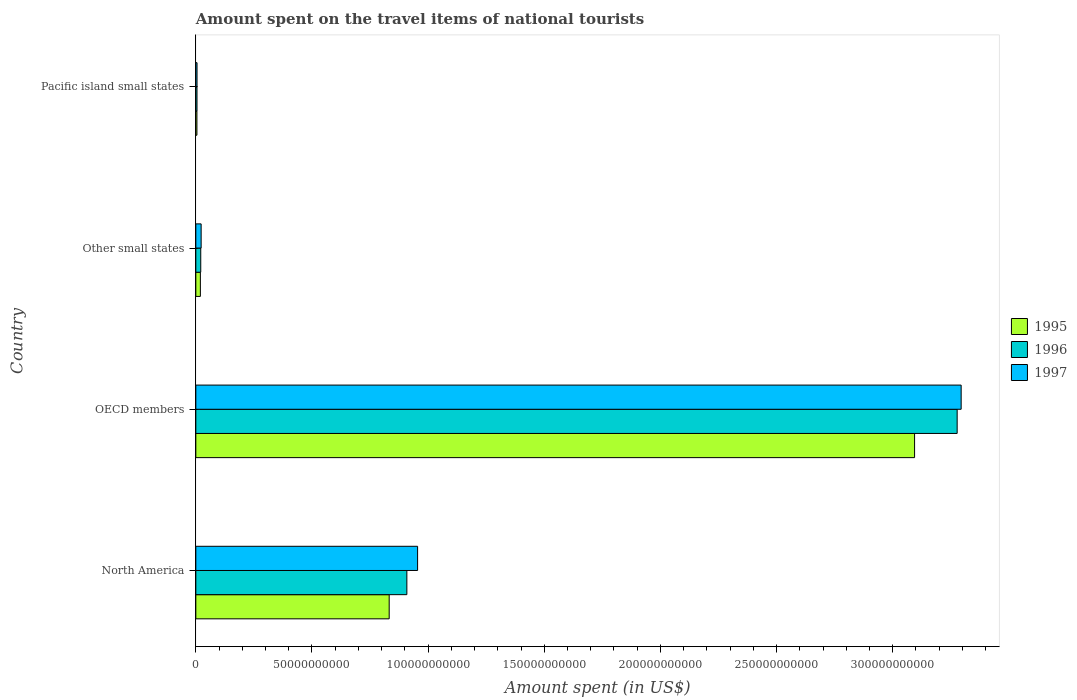How many different coloured bars are there?
Make the answer very short. 3. Are the number of bars on each tick of the Y-axis equal?
Keep it short and to the point. Yes. How many bars are there on the 1st tick from the top?
Provide a succinct answer. 3. How many bars are there on the 2nd tick from the bottom?
Provide a succinct answer. 3. What is the label of the 3rd group of bars from the top?
Ensure brevity in your answer.  OECD members. What is the amount spent on the travel items of national tourists in 1995 in Other small states?
Provide a succinct answer. 1.95e+09. Across all countries, what is the maximum amount spent on the travel items of national tourists in 1995?
Your answer should be very brief. 3.09e+11. Across all countries, what is the minimum amount spent on the travel items of national tourists in 1997?
Offer a very short reply. 5.15e+08. In which country was the amount spent on the travel items of national tourists in 1997 minimum?
Your answer should be compact. Pacific island small states. What is the total amount spent on the travel items of national tourists in 1997 in the graph?
Offer a very short reply. 4.28e+11. What is the difference between the amount spent on the travel items of national tourists in 1996 in OECD members and that in Other small states?
Ensure brevity in your answer.  3.26e+11. What is the difference between the amount spent on the travel items of national tourists in 1995 in North America and the amount spent on the travel items of national tourists in 1997 in Pacific island small states?
Provide a short and direct response. 8.27e+1. What is the average amount spent on the travel items of national tourists in 1996 per country?
Keep it short and to the point. 1.05e+11. What is the difference between the amount spent on the travel items of national tourists in 1995 and amount spent on the travel items of national tourists in 1996 in Pacific island small states?
Your answer should be very brief. -2.89e+07. What is the ratio of the amount spent on the travel items of national tourists in 1995 in OECD members to that in Other small states?
Keep it short and to the point. 158.36. What is the difference between the highest and the second highest amount spent on the travel items of national tourists in 1997?
Your response must be concise. 2.34e+11. What is the difference between the highest and the lowest amount spent on the travel items of national tourists in 1997?
Make the answer very short. 3.29e+11. In how many countries, is the amount spent on the travel items of national tourists in 1996 greater than the average amount spent on the travel items of national tourists in 1996 taken over all countries?
Give a very brief answer. 1. Is the sum of the amount spent on the travel items of national tourists in 1997 in North America and Other small states greater than the maximum amount spent on the travel items of national tourists in 1996 across all countries?
Keep it short and to the point. No. How many bars are there?
Provide a short and direct response. 12. What is the difference between two consecutive major ticks on the X-axis?
Your response must be concise. 5.00e+1. Are the values on the major ticks of X-axis written in scientific E-notation?
Make the answer very short. No. Does the graph contain any zero values?
Offer a very short reply. No. How are the legend labels stacked?
Your answer should be very brief. Vertical. What is the title of the graph?
Provide a short and direct response. Amount spent on the travel items of national tourists. Does "1989" appear as one of the legend labels in the graph?
Your answer should be compact. No. What is the label or title of the X-axis?
Provide a succinct answer. Amount spent (in US$). What is the label or title of the Y-axis?
Make the answer very short. Country. What is the Amount spent (in US$) in 1995 in North America?
Provide a short and direct response. 8.32e+1. What is the Amount spent (in US$) in 1996 in North America?
Give a very brief answer. 9.09e+1. What is the Amount spent (in US$) in 1997 in North America?
Your answer should be compact. 9.55e+1. What is the Amount spent (in US$) of 1995 in OECD members?
Make the answer very short. 3.09e+11. What is the Amount spent (in US$) of 1996 in OECD members?
Make the answer very short. 3.28e+11. What is the Amount spent (in US$) in 1997 in OECD members?
Provide a short and direct response. 3.29e+11. What is the Amount spent (in US$) of 1995 in Other small states?
Provide a succinct answer. 1.95e+09. What is the Amount spent (in US$) of 1996 in Other small states?
Ensure brevity in your answer.  2.12e+09. What is the Amount spent (in US$) in 1997 in Other small states?
Give a very brief answer. 2.29e+09. What is the Amount spent (in US$) of 1995 in Pacific island small states?
Give a very brief answer. 4.74e+08. What is the Amount spent (in US$) of 1996 in Pacific island small states?
Your response must be concise. 5.03e+08. What is the Amount spent (in US$) of 1997 in Pacific island small states?
Your answer should be compact. 5.15e+08. Across all countries, what is the maximum Amount spent (in US$) in 1995?
Keep it short and to the point. 3.09e+11. Across all countries, what is the maximum Amount spent (in US$) in 1996?
Your answer should be very brief. 3.28e+11. Across all countries, what is the maximum Amount spent (in US$) in 1997?
Make the answer very short. 3.29e+11. Across all countries, what is the minimum Amount spent (in US$) of 1995?
Your answer should be very brief. 4.74e+08. Across all countries, what is the minimum Amount spent (in US$) in 1996?
Your answer should be very brief. 5.03e+08. Across all countries, what is the minimum Amount spent (in US$) in 1997?
Offer a very short reply. 5.15e+08. What is the total Amount spent (in US$) in 1995 in the graph?
Your answer should be compact. 3.95e+11. What is the total Amount spent (in US$) of 1996 in the graph?
Give a very brief answer. 4.21e+11. What is the total Amount spent (in US$) in 1997 in the graph?
Make the answer very short. 4.28e+11. What is the difference between the Amount spent (in US$) of 1995 in North America and that in OECD members?
Your answer should be very brief. -2.26e+11. What is the difference between the Amount spent (in US$) of 1996 in North America and that in OECD members?
Offer a terse response. -2.37e+11. What is the difference between the Amount spent (in US$) of 1997 in North America and that in OECD members?
Make the answer very short. -2.34e+11. What is the difference between the Amount spent (in US$) of 1995 in North America and that in Other small states?
Provide a succinct answer. 8.13e+1. What is the difference between the Amount spent (in US$) of 1996 in North America and that in Other small states?
Provide a short and direct response. 8.87e+1. What is the difference between the Amount spent (in US$) in 1997 in North America and that in Other small states?
Offer a very short reply. 9.32e+1. What is the difference between the Amount spent (in US$) of 1995 in North America and that in Pacific island small states?
Your response must be concise. 8.28e+1. What is the difference between the Amount spent (in US$) of 1996 in North America and that in Pacific island small states?
Ensure brevity in your answer.  9.03e+1. What is the difference between the Amount spent (in US$) in 1997 in North America and that in Pacific island small states?
Provide a succinct answer. 9.50e+1. What is the difference between the Amount spent (in US$) of 1995 in OECD members and that in Other small states?
Ensure brevity in your answer.  3.07e+11. What is the difference between the Amount spent (in US$) in 1996 in OECD members and that in Other small states?
Your answer should be compact. 3.26e+11. What is the difference between the Amount spent (in US$) in 1997 in OECD members and that in Other small states?
Your response must be concise. 3.27e+11. What is the difference between the Amount spent (in US$) of 1995 in OECD members and that in Pacific island small states?
Keep it short and to the point. 3.09e+11. What is the difference between the Amount spent (in US$) in 1996 in OECD members and that in Pacific island small states?
Keep it short and to the point. 3.27e+11. What is the difference between the Amount spent (in US$) in 1997 in OECD members and that in Pacific island small states?
Provide a short and direct response. 3.29e+11. What is the difference between the Amount spent (in US$) in 1995 in Other small states and that in Pacific island small states?
Keep it short and to the point. 1.48e+09. What is the difference between the Amount spent (in US$) in 1996 in Other small states and that in Pacific island small states?
Provide a succinct answer. 1.62e+09. What is the difference between the Amount spent (in US$) of 1997 in Other small states and that in Pacific island small states?
Your answer should be very brief. 1.77e+09. What is the difference between the Amount spent (in US$) of 1995 in North America and the Amount spent (in US$) of 1996 in OECD members?
Make the answer very short. -2.45e+11. What is the difference between the Amount spent (in US$) of 1995 in North America and the Amount spent (in US$) of 1997 in OECD members?
Provide a succinct answer. -2.46e+11. What is the difference between the Amount spent (in US$) in 1996 in North America and the Amount spent (in US$) in 1997 in OECD members?
Your answer should be very brief. -2.39e+11. What is the difference between the Amount spent (in US$) of 1995 in North America and the Amount spent (in US$) of 1996 in Other small states?
Make the answer very short. 8.11e+1. What is the difference between the Amount spent (in US$) in 1995 in North America and the Amount spent (in US$) in 1997 in Other small states?
Offer a very short reply. 8.10e+1. What is the difference between the Amount spent (in US$) of 1996 in North America and the Amount spent (in US$) of 1997 in Other small states?
Your response must be concise. 8.86e+1. What is the difference between the Amount spent (in US$) of 1995 in North America and the Amount spent (in US$) of 1996 in Pacific island small states?
Provide a succinct answer. 8.27e+1. What is the difference between the Amount spent (in US$) of 1995 in North America and the Amount spent (in US$) of 1997 in Pacific island small states?
Offer a terse response. 8.27e+1. What is the difference between the Amount spent (in US$) of 1996 in North America and the Amount spent (in US$) of 1997 in Pacific island small states?
Your response must be concise. 9.03e+1. What is the difference between the Amount spent (in US$) of 1995 in OECD members and the Amount spent (in US$) of 1996 in Other small states?
Give a very brief answer. 3.07e+11. What is the difference between the Amount spent (in US$) of 1995 in OECD members and the Amount spent (in US$) of 1997 in Other small states?
Offer a terse response. 3.07e+11. What is the difference between the Amount spent (in US$) of 1996 in OECD members and the Amount spent (in US$) of 1997 in Other small states?
Provide a short and direct response. 3.25e+11. What is the difference between the Amount spent (in US$) in 1995 in OECD members and the Amount spent (in US$) in 1996 in Pacific island small states?
Your answer should be compact. 3.09e+11. What is the difference between the Amount spent (in US$) of 1995 in OECD members and the Amount spent (in US$) of 1997 in Pacific island small states?
Ensure brevity in your answer.  3.09e+11. What is the difference between the Amount spent (in US$) of 1996 in OECD members and the Amount spent (in US$) of 1997 in Pacific island small states?
Provide a succinct answer. 3.27e+11. What is the difference between the Amount spent (in US$) in 1995 in Other small states and the Amount spent (in US$) in 1996 in Pacific island small states?
Your response must be concise. 1.45e+09. What is the difference between the Amount spent (in US$) of 1995 in Other small states and the Amount spent (in US$) of 1997 in Pacific island small states?
Your answer should be compact. 1.44e+09. What is the difference between the Amount spent (in US$) in 1996 in Other small states and the Amount spent (in US$) in 1997 in Pacific island small states?
Your answer should be compact. 1.60e+09. What is the average Amount spent (in US$) of 1995 per country?
Offer a terse response. 9.88e+1. What is the average Amount spent (in US$) of 1996 per country?
Provide a succinct answer. 1.05e+11. What is the average Amount spent (in US$) of 1997 per country?
Provide a succinct answer. 1.07e+11. What is the difference between the Amount spent (in US$) of 1995 and Amount spent (in US$) of 1996 in North America?
Give a very brief answer. -7.61e+09. What is the difference between the Amount spent (in US$) of 1995 and Amount spent (in US$) of 1997 in North America?
Your response must be concise. -1.22e+1. What is the difference between the Amount spent (in US$) in 1996 and Amount spent (in US$) in 1997 in North America?
Your answer should be very brief. -4.62e+09. What is the difference between the Amount spent (in US$) of 1995 and Amount spent (in US$) of 1996 in OECD members?
Ensure brevity in your answer.  -1.83e+1. What is the difference between the Amount spent (in US$) of 1995 and Amount spent (in US$) of 1997 in OECD members?
Provide a short and direct response. -2.01e+1. What is the difference between the Amount spent (in US$) of 1996 and Amount spent (in US$) of 1997 in OECD members?
Ensure brevity in your answer.  -1.72e+09. What is the difference between the Amount spent (in US$) in 1995 and Amount spent (in US$) in 1996 in Other small states?
Your response must be concise. -1.64e+08. What is the difference between the Amount spent (in US$) of 1995 and Amount spent (in US$) of 1997 in Other small states?
Provide a short and direct response. -3.34e+08. What is the difference between the Amount spent (in US$) in 1996 and Amount spent (in US$) in 1997 in Other small states?
Provide a short and direct response. -1.69e+08. What is the difference between the Amount spent (in US$) in 1995 and Amount spent (in US$) in 1996 in Pacific island small states?
Your answer should be very brief. -2.89e+07. What is the difference between the Amount spent (in US$) of 1995 and Amount spent (in US$) of 1997 in Pacific island small states?
Provide a succinct answer. -4.11e+07. What is the difference between the Amount spent (in US$) of 1996 and Amount spent (in US$) of 1997 in Pacific island small states?
Keep it short and to the point. -1.22e+07. What is the ratio of the Amount spent (in US$) of 1995 in North America to that in OECD members?
Give a very brief answer. 0.27. What is the ratio of the Amount spent (in US$) in 1996 in North America to that in OECD members?
Provide a succinct answer. 0.28. What is the ratio of the Amount spent (in US$) of 1997 in North America to that in OECD members?
Give a very brief answer. 0.29. What is the ratio of the Amount spent (in US$) in 1995 in North America to that in Other small states?
Make the answer very short. 42.6. What is the ratio of the Amount spent (in US$) in 1996 in North America to that in Other small states?
Ensure brevity in your answer.  42.89. What is the ratio of the Amount spent (in US$) of 1997 in North America to that in Other small states?
Provide a succinct answer. 41.73. What is the ratio of the Amount spent (in US$) of 1995 in North America to that in Pacific island small states?
Your answer should be very brief. 175.63. What is the ratio of the Amount spent (in US$) of 1996 in North America to that in Pacific island small states?
Make the answer very short. 180.67. What is the ratio of the Amount spent (in US$) in 1997 in North America to that in Pacific island small states?
Your answer should be compact. 185.36. What is the ratio of the Amount spent (in US$) in 1995 in OECD members to that in Other small states?
Your answer should be very brief. 158.36. What is the ratio of the Amount spent (in US$) of 1996 in OECD members to that in Other small states?
Your response must be concise. 154.72. What is the ratio of the Amount spent (in US$) of 1997 in OECD members to that in Other small states?
Keep it short and to the point. 144.02. What is the ratio of the Amount spent (in US$) of 1995 in OECD members to that in Pacific island small states?
Ensure brevity in your answer.  652.87. What is the ratio of the Amount spent (in US$) of 1996 in OECD members to that in Pacific island small states?
Offer a very short reply. 651.78. What is the ratio of the Amount spent (in US$) in 1997 in OECD members to that in Pacific island small states?
Give a very brief answer. 639.7. What is the ratio of the Amount spent (in US$) of 1995 in Other small states to that in Pacific island small states?
Your answer should be compact. 4.12. What is the ratio of the Amount spent (in US$) of 1996 in Other small states to that in Pacific island small states?
Provide a short and direct response. 4.21. What is the ratio of the Amount spent (in US$) of 1997 in Other small states to that in Pacific island small states?
Your response must be concise. 4.44. What is the difference between the highest and the second highest Amount spent (in US$) in 1995?
Ensure brevity in your answer.  2.26e+11. What is the difference between the highest and the second highest Amount spent (in US$) in 1996?
Offer a very short reply. 2.37e+11. What is the difference between the highest and the second highest Amount spent (in US$) of 1997?
Give a very brief answer. 2.34e+11. What is the difference between the highest and the lowest Amount spent (in US$) in 1995?
Provide a succinct answer. 3.09e+11. What is the difference between the highest and the lowest Amount spent (in US$) of 1996?
Your answer should be compact. 3.27e+11. What is the difference between the highest and the lowest Amount spent (in US$) in 1997?
Ensure brevity in your answer.  3.29e+11. 